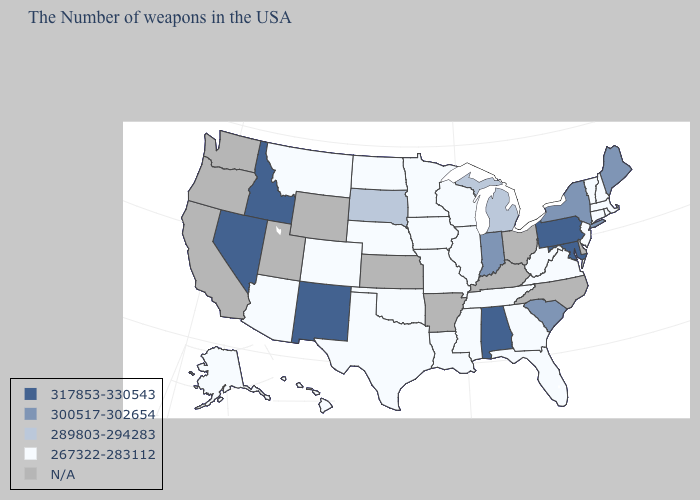Which states hav the highest value in the South?
Short answer required. Maryland, Alabama. Name the states that have a value in the range 289803-294283?
Write a very short answer. Michigan, South Dakota. What is the value of Virginia?
Quick response, please. 267322-283112. Which states hav the highest value in the South?
Concise answer only. Maryland, Alabama. What is the value of Montana?
Answer briefly. 267322-283112. What is the lowest value in states that border Utah?
Give a very brief answer. 267322-283112. Name the states that have a value in the range 267322-283112?
Short answer required. Massachusetts, Rhode Island, New Hampshire, Vermont, Connecticut, New Jersey, Virginia, West Virginia, Florida, Georgia, Tennessee, Wisconsin, Illinois, Mississippi, Louisiana, Missouri, Minnesota, Iowa, Nebraska, Oklahoma, Texas, North Dakota, Colorado, Montana, Arizona, Alaska, Hawaii. What is the value of Alaska?
Quick response, please. 267322-283112. What is the lowest value in the USA?
Keep it brief. 267322-283112. Name the states that have a value in the range 317853-330543?
Give a very brief answer. Maryland, Pennsylvania, Alabama, New Mexico, Idaho, Nevada. Name the states that have a value in the range 300517-302654?
Write a very short answer. Maine, New York, South Carolina, Indiana. What is the lowest value in the USA?
Keep it brief. 267322-283112. Name the states that have a value in the range 300517-302654?
Concise answer only. Maine, New York, South Carolina, Indiana. What is the lowest value in states that border Alabama?
Be succinct. 267322-283112. 